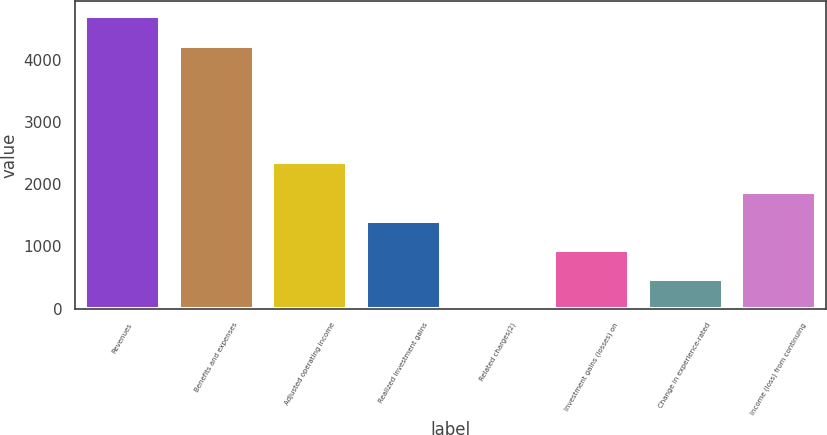<chart> <loc_0><loc_0><loc_500><loc_500><bar_chart><fcel>Revenues<fcel>Benefits and expenses<fcel>Adjusted operating income<fcel>Realized investment gains<fcel>Related charges(2)<fcel>Investment gains (losses) on<fcel>Change in experience-rated<fcel>Income (loss) from continuing<nl><fcel>4708<fcel>4226<fcel>2354.5<fcel>1413.1<fcel>1<fcel>942.4<fcel>471.7<fcel>1883.8<nl></chart> 